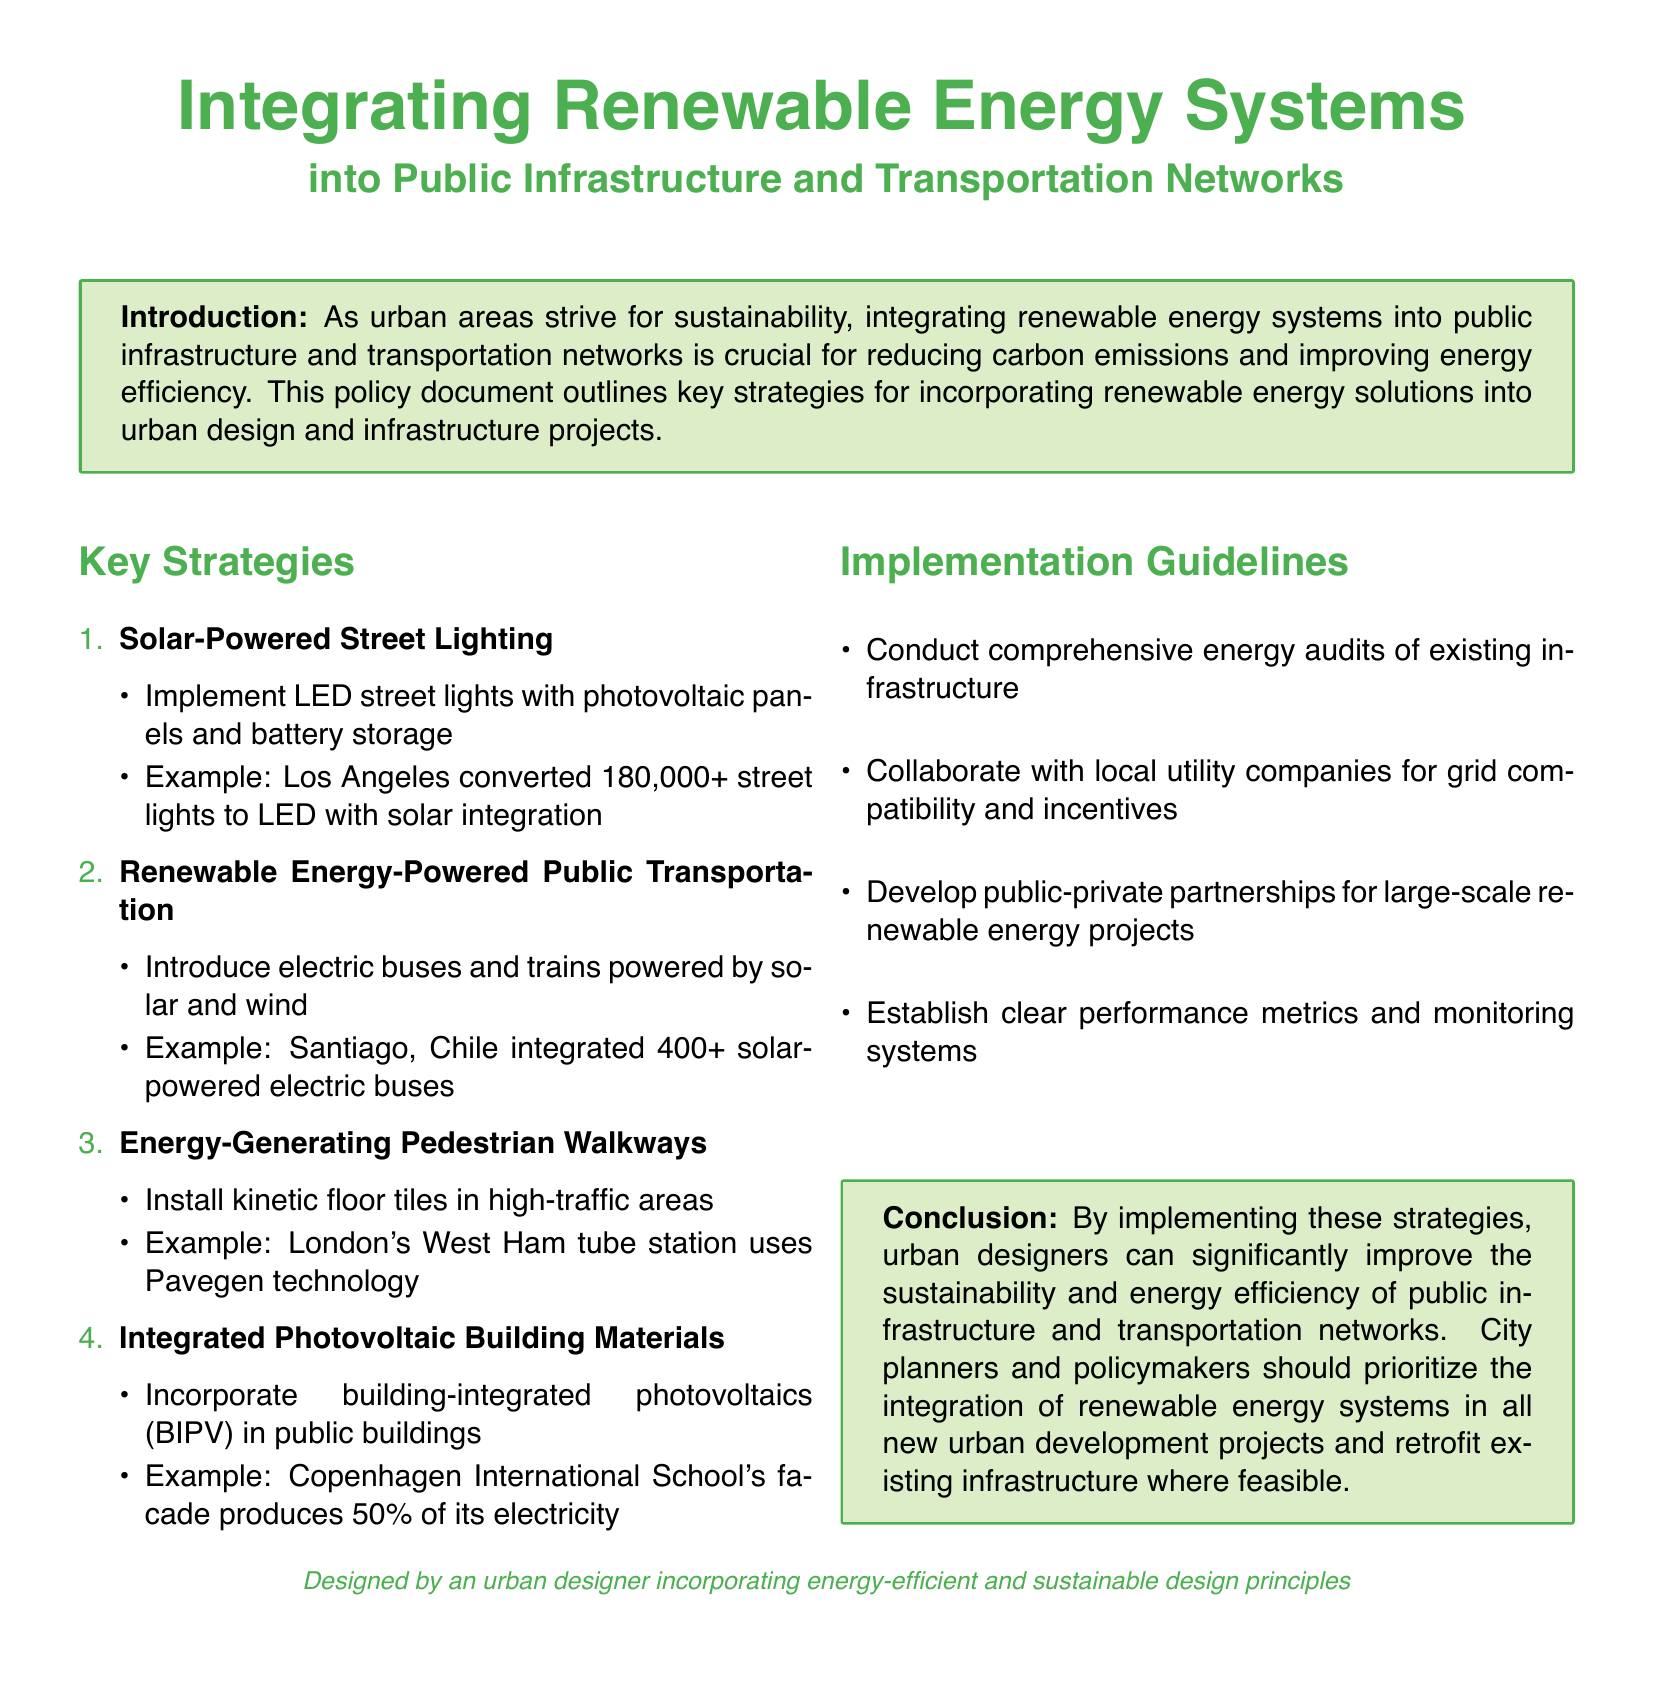What is a key benefit of integrating renewable energy systems into public infrastructure? The document states that integrating renewable energy systems is crucial for reducing carbon emissions and improving energy efficiency.
Answer: Reducing carbon emissions How many street lights were converted to LED in Los Angeles? The example in the document mentions that Los Angeles converted 180,000+ street lights to LED with solar integration.
Answer: 180,000+ What type of energy is used to power electric buses in Santiago, Chile? The document specifies that electric buses in Santiago, Chile are powered by solar and wind.
Answer: Solar and wind What technology is used in London's West Ham tube station? The document highlights the use of Pavegen technology in London's West Ham tube station for energy-generating walkways.
Answer: Pavegen What should be established for monitoring renewable energy projects? The implementation guidelines state that clear performance metrics and monitoring systems should be established for renewable energy projects.
Answer: Performance metrics Why should city planners prioritize renewable energy systems? The conclusion indicates that prioritizing renewable energy systems improves sustainability and energy efficiency in urban development projects.
Answer: Sustainability and energy efficiency What is one method for promoting collaboration in renewable energy projects? The guidelines suggest collaborating with local utility companies for grid compatibility and incentives.
Answer: Collaborating with local utility companies What type of partnerships is recommended in the document? The document recommends developing public-private partnerships for large-scale renewable energy projects.
Answer: Public-private partnerships What energy solution is provided by integrated photovoltaic building materials? The example of Copenhagen International School states that its facade produces 50% of its electricity using building-integrated photovoltaics.
Answer: 50% of its electricity 